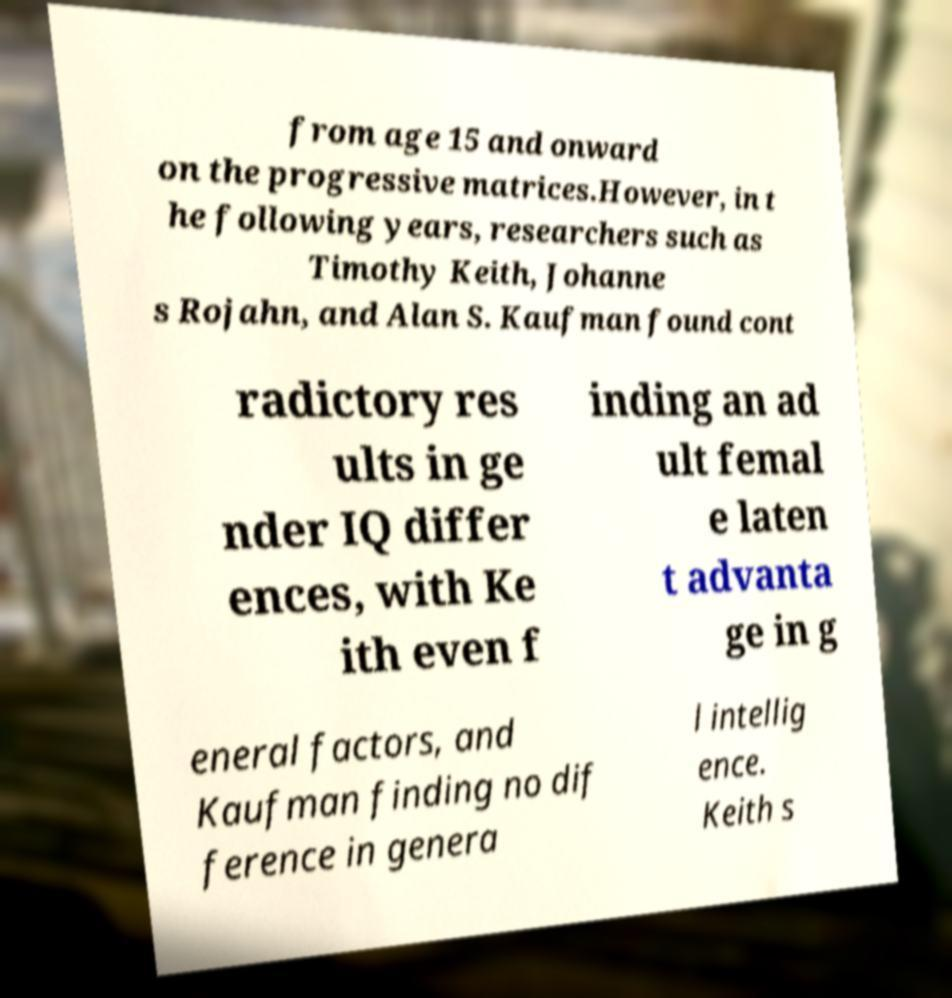For documentation purposes, I need the text within this image transcribed. Could you provide that? from age 15 and onward on the progressive matrices.However, in t he following years, researchers such as Timothy Keith, Johanne s Rojahn, and Alan S. Kaufman found cont radictory res ults in ge nder IQ differ ences, with Ke ith even f inding an ad ult femal e laten t advanta ge in g eneral factors, and Kaufman finding no dif ference in genera l intellig ence. Keith s 